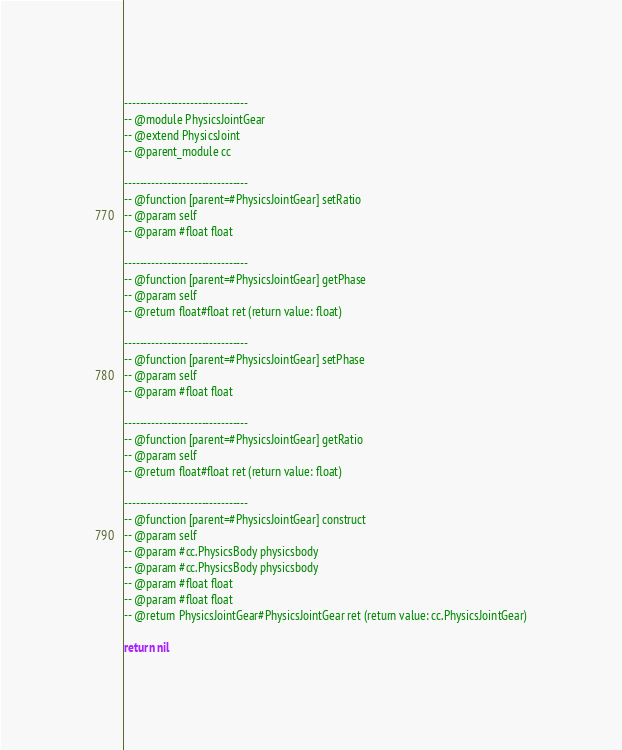Convert code to text. <code><loc_0><loc_0><loc_500><loc_500><_Lua_>
--------------------------------
-- @module PhysicsJointGear
-- @extend PhysicsJoint
-- @parent_module cc

--------------------------------
-- @function [parent=#PhysicsJointGear] setRatio 
-- @param self
-- @param #float float
        
--------------------------------
-- @function [parent=#PhysicsJointGear] getPhase 
-- @param self
-- @return float#float ret (return value: float)
        
--------------------------------
-- @function [parent=#PhysicsJointGear] setPhase 
-- @param self
-- @param #float float
        
--------------------------------
-- @function [parent=#PhysicsJointGear] getRatio 
-- @param self
-- @return float#float ret (return value: float)
        
--------------------------------
-- @function [parent=#PhysicsJointGear] construct 
-- @param self
-- @param #cc.PhysicsBody physicsbody
-- @param #cc.PhysicsBody physicsbody
-- @param #float float
-- @param #float float
-- @return PhysicsJointGear#PhysicsJointGear ret (return value: cc.PhysicsJointGear)
        
return nil
</code> 